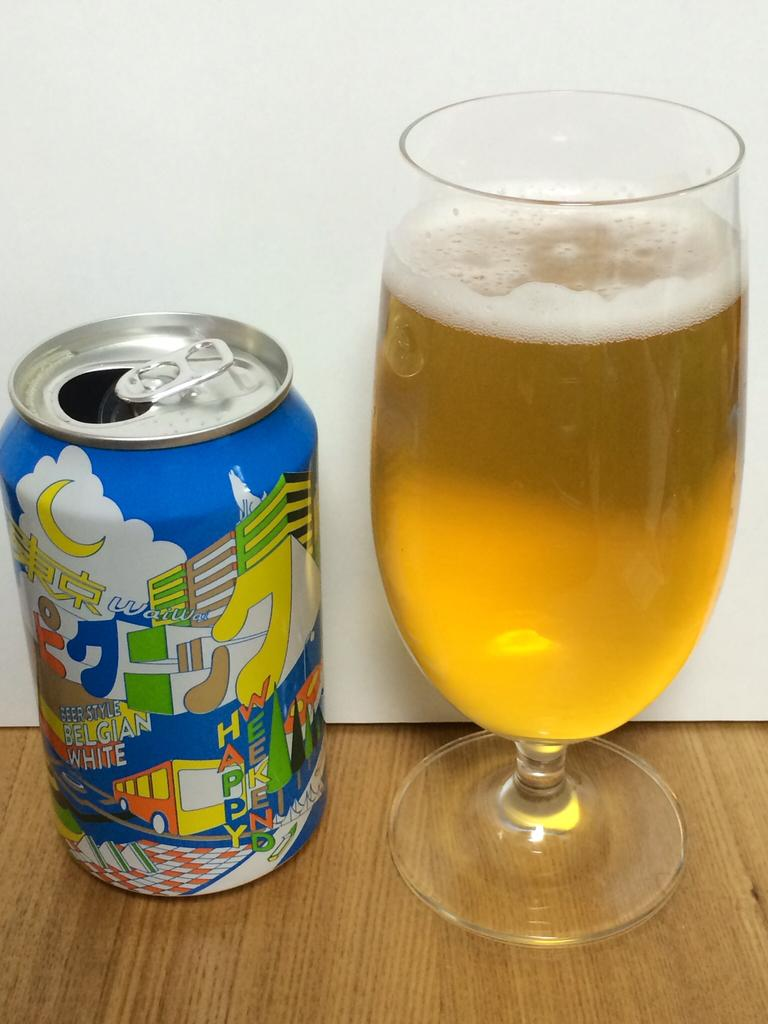Provide a one-sentence caption for the provided image. A can of beer style belgian white next to a full glass. 